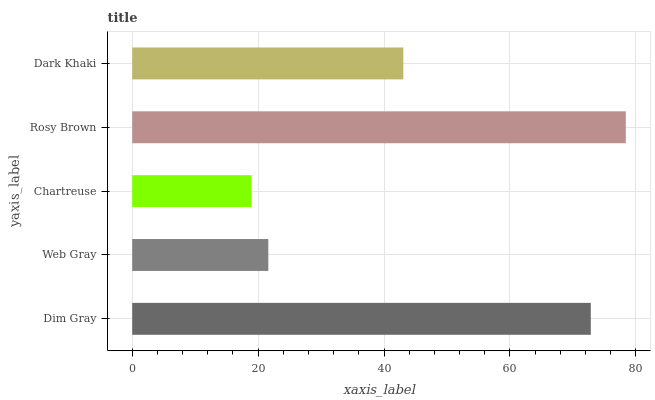Is Chartreuse the minimum?
Answer yes or no. Yes. Is Rosy Brown the maximum?
Answer yes or no. Yes. Is Web Gray the minimum?
Answer yes or no. No. Is Web Gray the maximum?
Answer yes or no. No. Is Dim Gray greater than Web Gray?
Answer yes or no. Yes. Is Web Gray less than Dim Gray?
Answer yes or no. Yes. Is Web Gray greater than Dim Gray?
Answer yes or no. No. Is Dim Gray less than Web Gray?
Answer yes or no. No. Is Dark Khaki the high median?
Answer yes or no. Yes. Is Dark Khaki the low median?
Answer yes or no. Yes. Is Chartreuse the high median?
Answer yes or no. No. Is Chartreuse the low median?
Answer yes or no. No. 